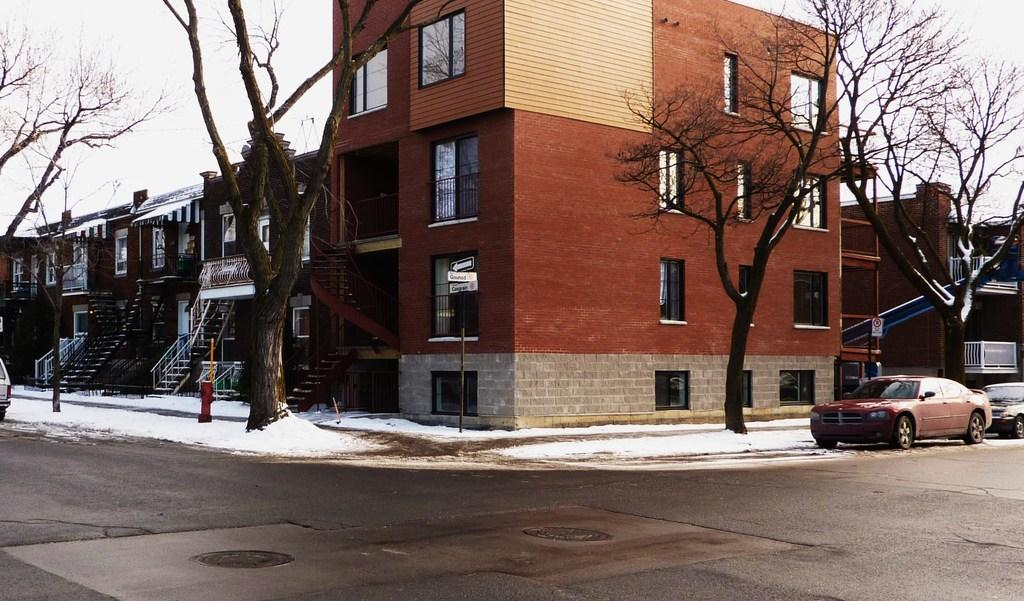What type of structures are present in the image? There are buildings with stairs in the image. What is covering the ground in the image? There is snow on the ground in the image. What type of vegetation can be seen in the image? There are trees in the image. What type of transportation is visible in the image? There are vehicles on the road in the image. What part of the natural environment is visible in the image? The sky is visible in the image. What color is the sweater worn by the copper statue in the image? There is no sweater or copper statue present in the image. What type of joke is being told by the trees in the image? There are no jokes being told by the trees in the image; they are simply trees. 